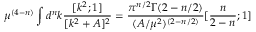<formula> <loc_0><loc_0><loc_500><loc_500>\mu ^ { ( 4 - n ) } \int d ^ { n } k \frac { [ k ^ { 2 } ; 1 ] } { [ k ^ { 2 } + A ] ^ { 2 } } = \frac { \pi ^ { n / 2 } \Gamma ( 2 - n / 2 ) } { ( A / \mu ^ { 2 } ) ^ { ( 2 - n / 2 ) } } [ \frac { n } { 2 - n } ; 1 ]</formula> 